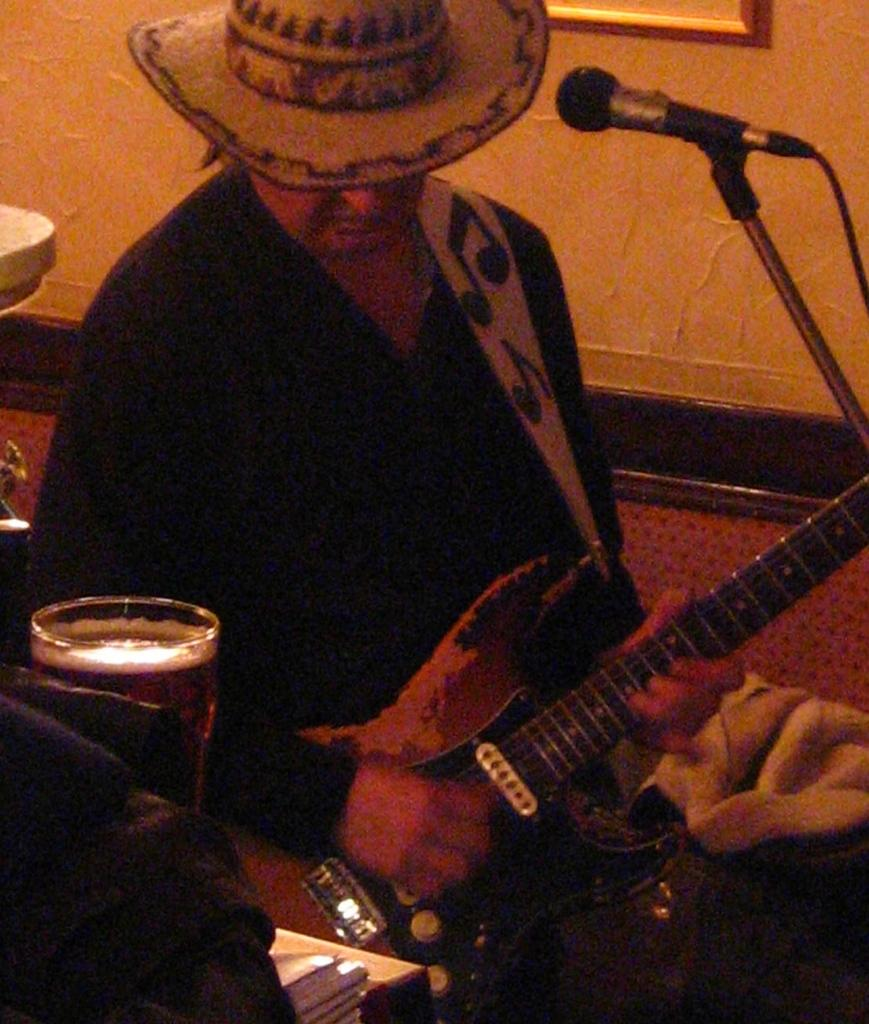Who is present in the image? There is a person in the image. What is the person holding? The person is holding a guitar. What accessory is the person wearing? The person is wearing a hat. What other object can be seen in the image? There is a microphone (mic) in the image. What might the person be using for drinking? There is a glass in the image. How many eggs are visible on the person's head in the image? There are no eggs visible on the person's head in the image. What type of recess can be seen in the image? There is no recess present in the image. 